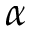Convert formula to latex. <formula><loc_0><loc_0><loc_500><loc_500>\alpha</formula> 